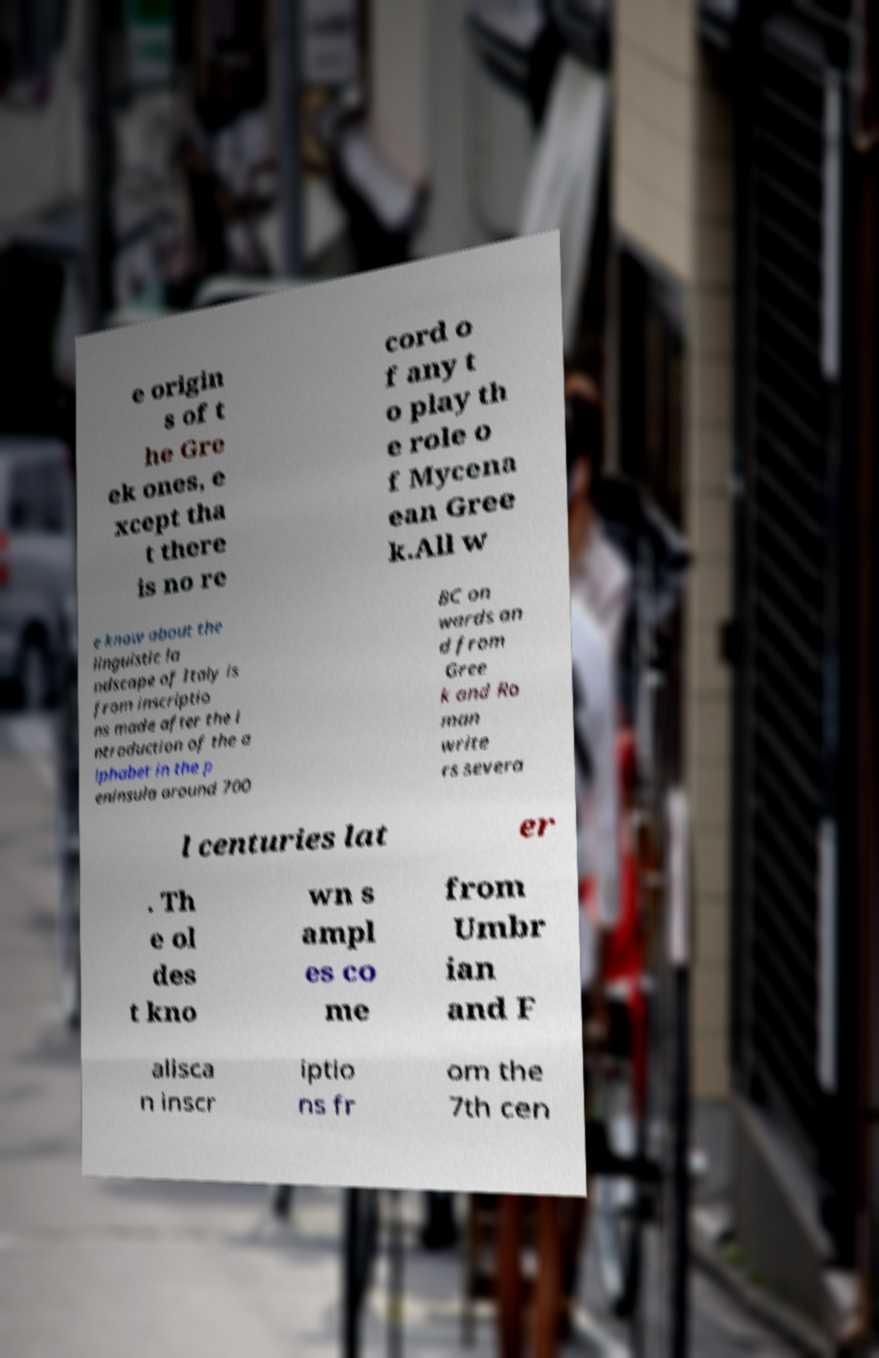I need the written content from this picture converted into text. Can you do that? e origin s of t he Gre ek ones, e xcept tha t there is no re cord o f any t o play th e role o f Mycena ean Gree k.All w e know about the linguistic la ndscape of Italy is from inscriptio ns made after the i ntroduction of the a lphabet in the p eninsula around 700 BC on wards an d from Gree k and Ro man write rs severa l centuries lat er . Th e ol des t kno wn s ampl es co me from Umbr ian and F alisca n inscr iptio ns fr om the 7th cen 